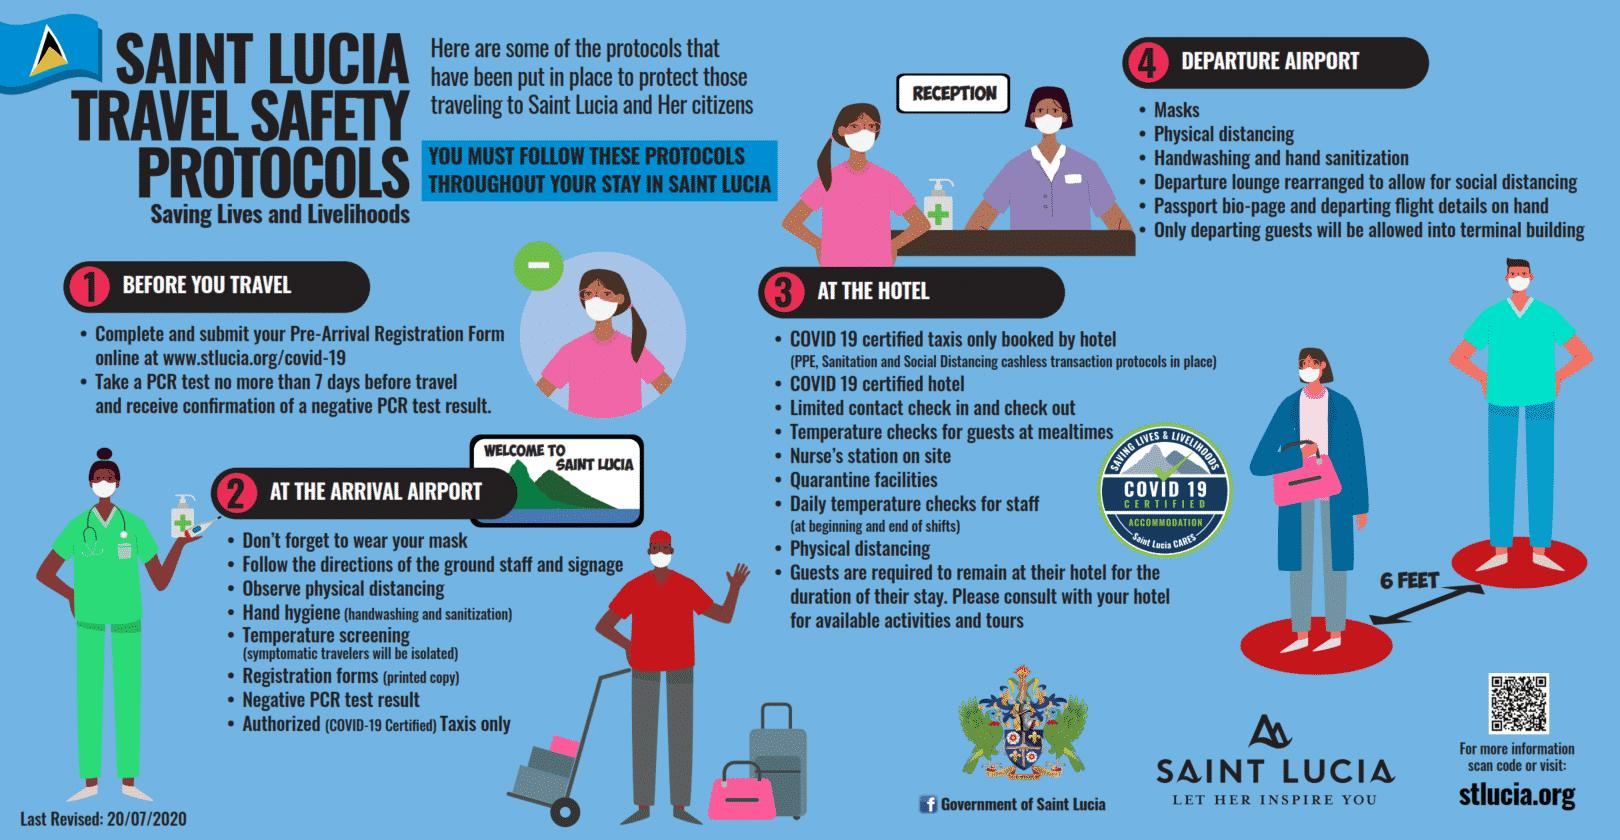Specify some key components in this picture. Four times has physical/social distancing been mentioned. The recommendation for physical distancing in the event of a COVID-19 positive case is 6 feet. 